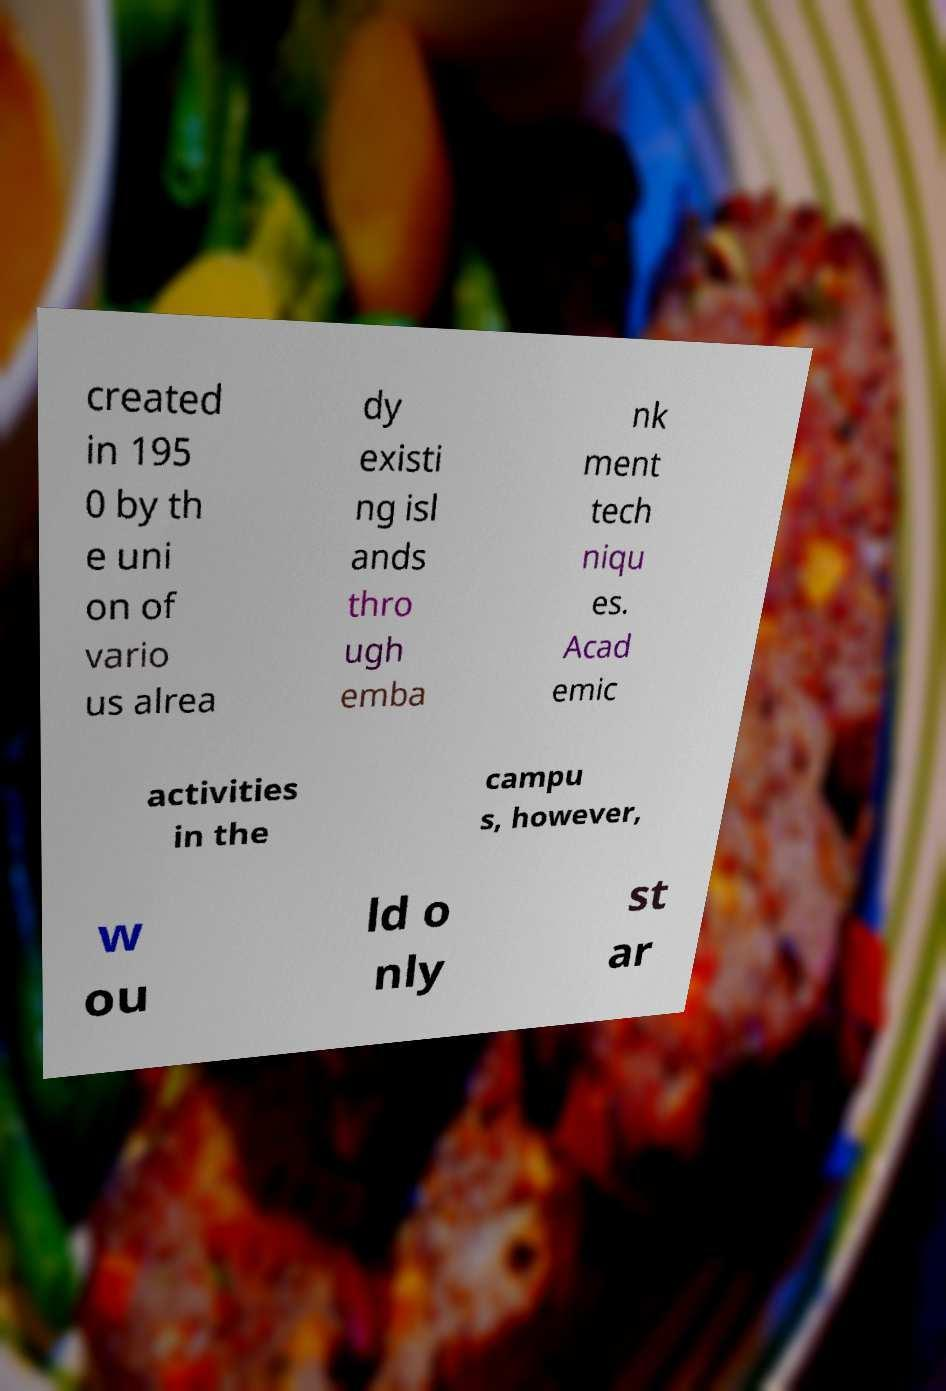Can you accurately transcribe the text from the provided image for me? created in 195 0 by th e uni on of vario us alrea dy existi ng isl ands thro ugh emba nk ment tech niqu es. Acad emic activities in the campu s, however, w ou ld o nly st ar 